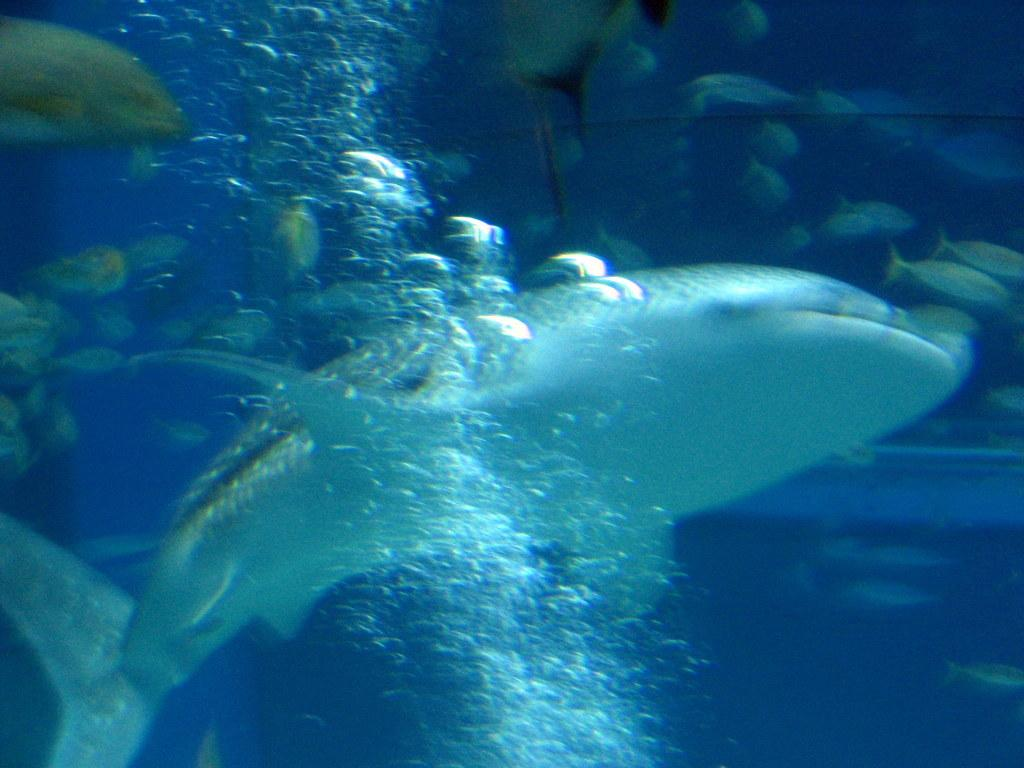What type of marine animal is present in the image? There is a shark in the image. Are there any other marine animals in the image? Yes, there are fishes in the image. What are the shark and fishes doing in the image? The shark and fishes are swimming in the water. What type of trail can be seen in the image? There is no trail present in the image; it features a shark and fishes swimming in the water. 